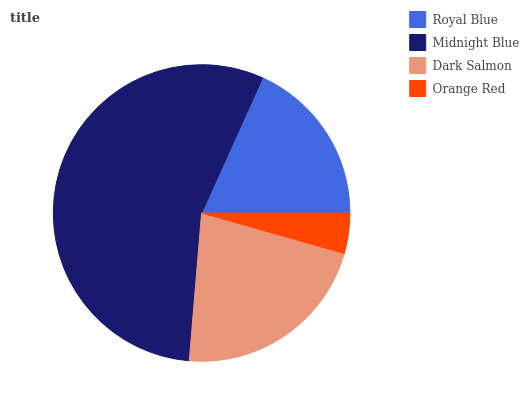Is Orange Red the minimum?
Answer yes or no. Yes. Is Midnight Blue the maximum?
Answer yes or no. Yes. Is Dark Salmon the minimum?
Answer yes or no. No. Is Dark Salmon the maximum?
Answer yes or no. No. Is Midnight Blue greater than Dark Salmon?
Answer yes or no. Yes. Is Dark Salmon less than Midnight Blue?
Answer yes or no. Yes. Is Dark Salmon greater than Midnight Blue?
Answer yes or no. No. Is Midnight Blue less than Dark Salmon?
Answer yes or no. No. Is Dark Salmon the high median?
Answer yes or no. Yes. Is Royal Blue the low median?
Answer yes or no. Yes. Is Midnight Blue the high median?
Answer yes or no. No. Is Dark Salmon the low median?
Answer yes or no. No. 